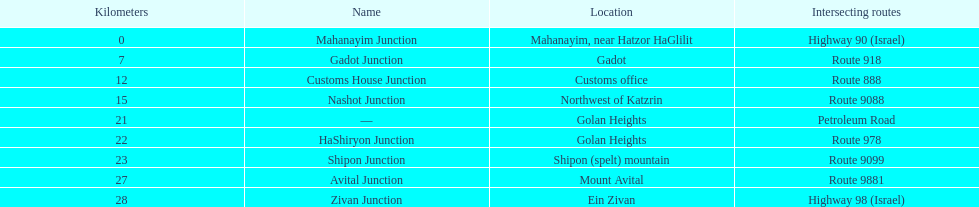What are the junctions that intersect a certain route? Gadot Junction, Customs House Junction, Nashot Junction, HaShiryon Junction, Shipon Junction, Avital Junction. Of these, which has a name that partially matches its location's name? Gadot Junction, Customs House Junction, Shipon Junction, Avital Junction. Which one is not found in a location named after a mountain? Gadot Junction, Customs House Junction. And which one possesses the highest route number? Gadot Junction. 